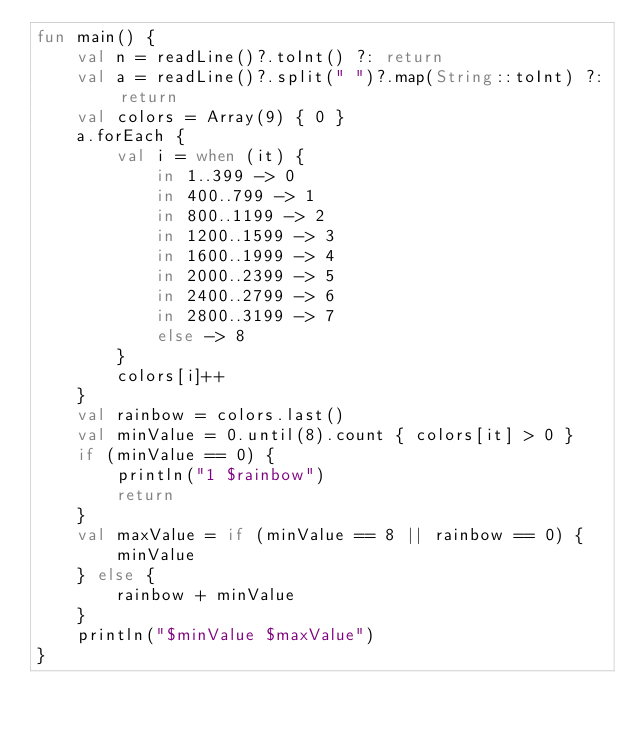Convert code to text. <code><loc_0><loc_0><loc_500><loc_500><_Kotlin_>fun main() {
    val n = readLine()?.toInt() ?: return
    val a = readLine()?.split(" ")?.map(String::toInt) ?: return
    val colors = Array(9) { 0 }
    a.forEach {
        val i = when (it) {
            in 1..399 -> 0
            in 400..799 -> 1
            in 800..1199 -> 2
            in 1200..1599 -> 3
            in 1600..1999 -> 4
            in 2000..2399 -> 5
            in 2400..2799 -> 6
            in 2800..3199 -> 7
            else -> 8
        }
        colors[i]++
    }
    val rainbow = colors.last()
    val minValue = 0.until(8).count { colors[it] > 0 }
    if (minValue == 0) {
        println("1 $rainbow")
        return
    }
    val maxValue = if (minValue == 8 || rainbow == 0) {
        minValue
    } else {
        rainbow + minValue
    }
    println("$minValue $maxValue")
}
</code> 